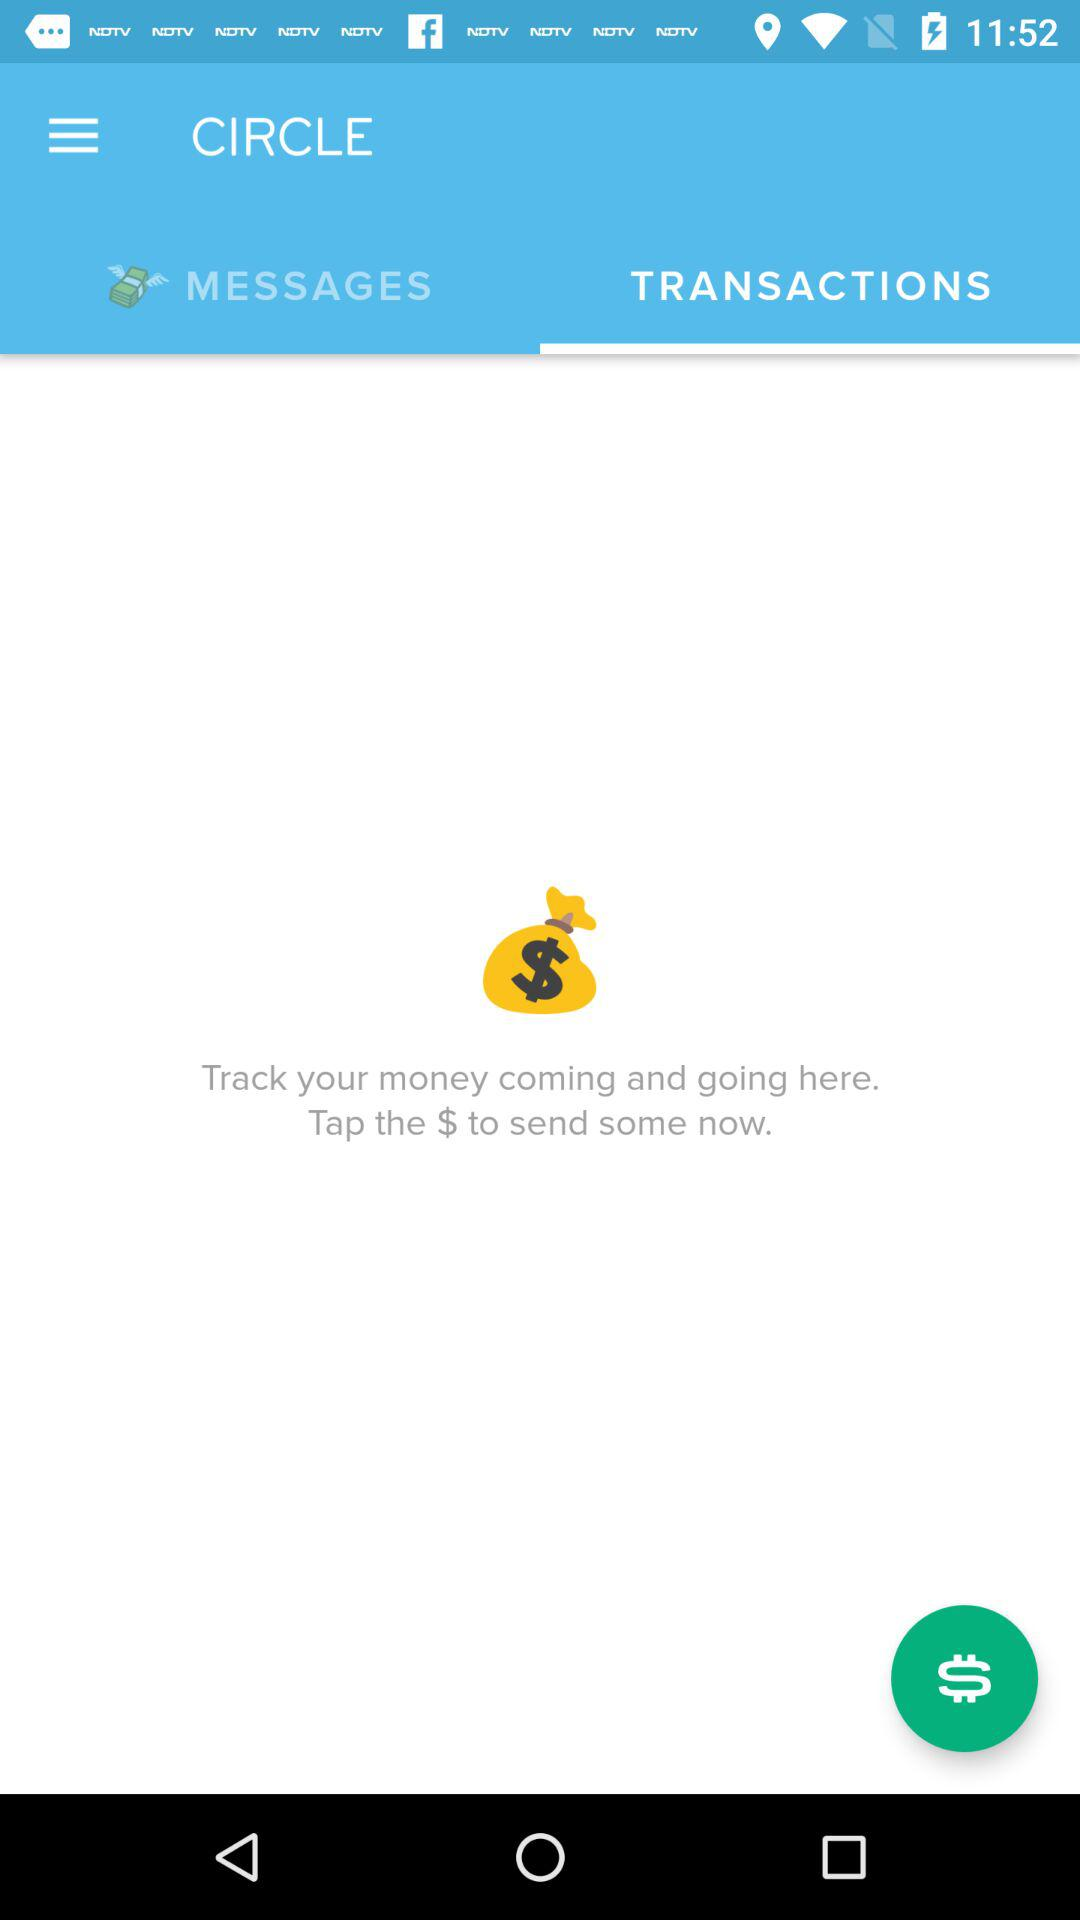How many messages are there?
When the provided information is insufficient, respond with <no answer>. <no answer> 